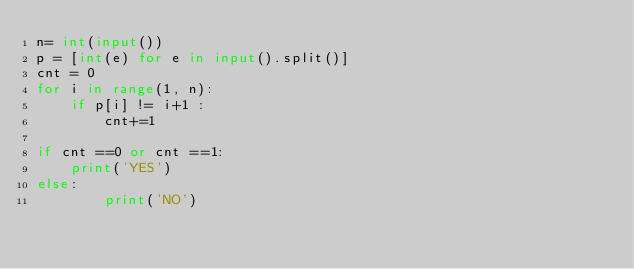Convert code to text. <code><loc_0><loc_0><loc_500><loc_500><_Python_>n= int(input())
p = [int(e) for e in input().split()]
cnt = 0
for i in range(1, n):
    if p[i] != i+1 :
        cnt+=1

if cnt ==0 or cnt ==1:
    print('YES')
else:
        print('NO')</code> 